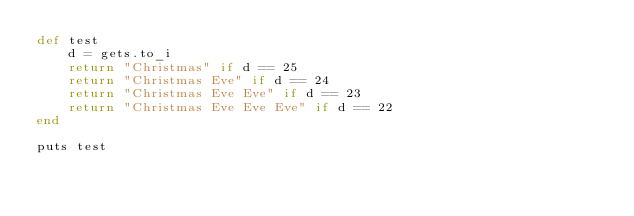<code> <loc_0><loc_0><loc_500><loc_500><_Ruby_>def test
	d = gets.to_i
	return "Christmas" if d == 25
	return "Christmas Eve" if d == 24
	return "Christmas Eve Eve" if d == 23
	return "Christmas Eve Eve Eve" if d == 22
end

puts test
</code> 